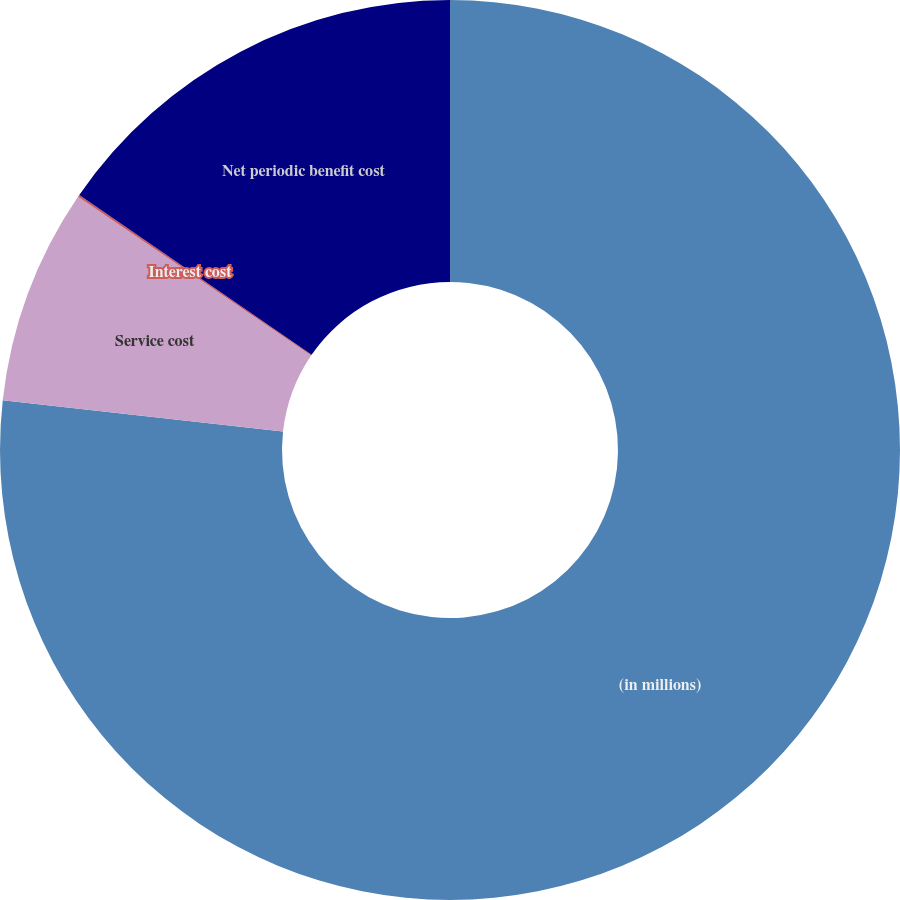Convert chart. <chart><loc_0><loc_0><loc_500><loc_500><pie_chart><fcel>(in millions)<fcel>Service cost<fcel>Interest cost<fcel>Net periodic benefit cost<nl><fcel>76.76%<fcel>7.75%<fcel>0.08%<fcel>15.41%<nl></chart> 